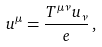<formula> <loc_0><loc_0><loc_500><loc_500>u ^ { \mu } = \frac { T ^ { \mu \nu } u _ { \nu } } { e } \, ,</formula> 